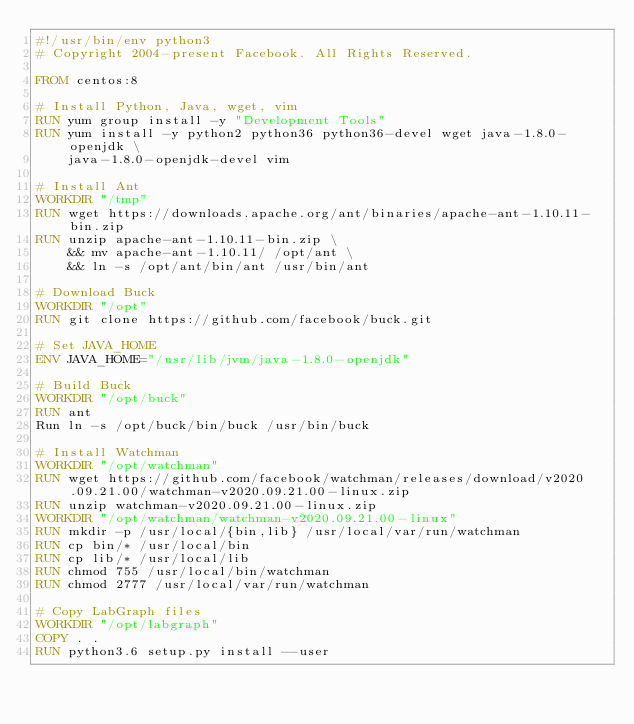Convert code to text. <code><loc_0><loc_0><loc_500><loc_500><_Dockerfile_>#!/usr/bin/env python3
# Copyright 2004-present Facebook. All Rights Reserved.

FROM centos:8

# Install Python, Java, wget, vim
RUN yum group install -y "Development Tools"
RUN yum install -y python2 python36 python36-devel wget java-1.8.0-openjdk \
    java-1.8.0-openjdk-devel vim

# Install Ant
WORKDIR "/tmp"
RUN wget https://downloads.apache.org/ant/binaries/apache-ant-1.10.11-bin.zip
RUN unzip apache-ant-1.10.11-bin.zip \
    && mv apache-ant-1.10.11/ /opt/ant \
    && ln -s /opt/ant/bin/ant /usr/bin/ant

# Download Buck
WORKDIR "/opt"
RUN git clone https://github.com/facebook/buck.git

# Set JAVA_HOME
ENV JAVA_HOME="/usr/lib/jvm/java-1.8.0-openjdk"

# Build Buck
WORKDIR "/opt/buck"
RUN ant
Run ln -s /opt/buck/bin/buck /usr/bin/buck

# Install Watchman
WORKDIR "/opt/watchman"
RUN wget https://github.com/facebook/watchman/releases/download/v2020.09.21.00/watchman-v2020.09.21.00-linux.zip
RUN unzip watchman-v2020.09.21.00-linux.zip
WORKDIR "/opt/watchman/watchman-v2020.09.21.00-linux"
RUN mkdir -p /usr/local/{bin,lib} /usr/local/var/run/watchman
RUN cp bin/* /usr/local/bin
RUN cp lib/* /usr/local/lib
RUN chmod 755 /usr/local/bin/watchman
RUN chmod 2777 /usr/local/var/run/watchman

# Copy LabGraph files
WORKDIR "/opt/labgraph"
COPY . .
RUN python3.6 setup.py install --user
</code> 